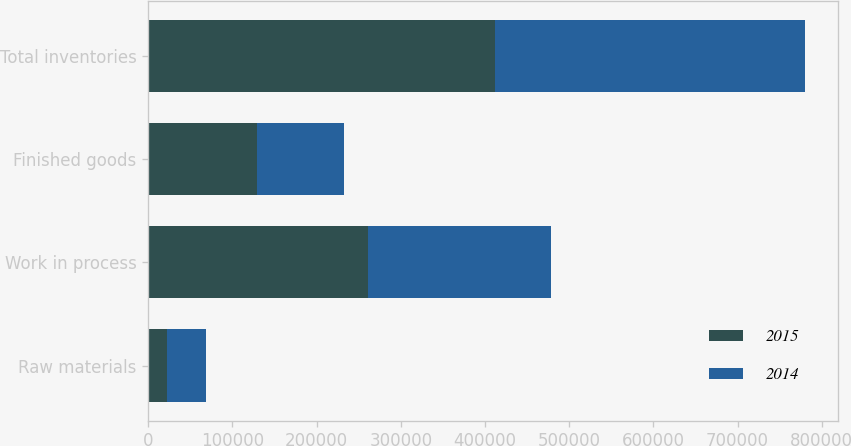Convert chart. <chart><loc_0><loc_0><loc_500><loc_500><stacked_bar_chart><ecel><fcel>Raw materials<fcel>Work in process<fcel>Finished goods<fcel>Total inventories<nl><fcel>2015<fcel>21825<fcel>261520<fcel>128969<fcel>412314<nl><fcel>2014<fcel>47267<fcel>216765<fcel>103895<fcel>367927<nl></chart> 